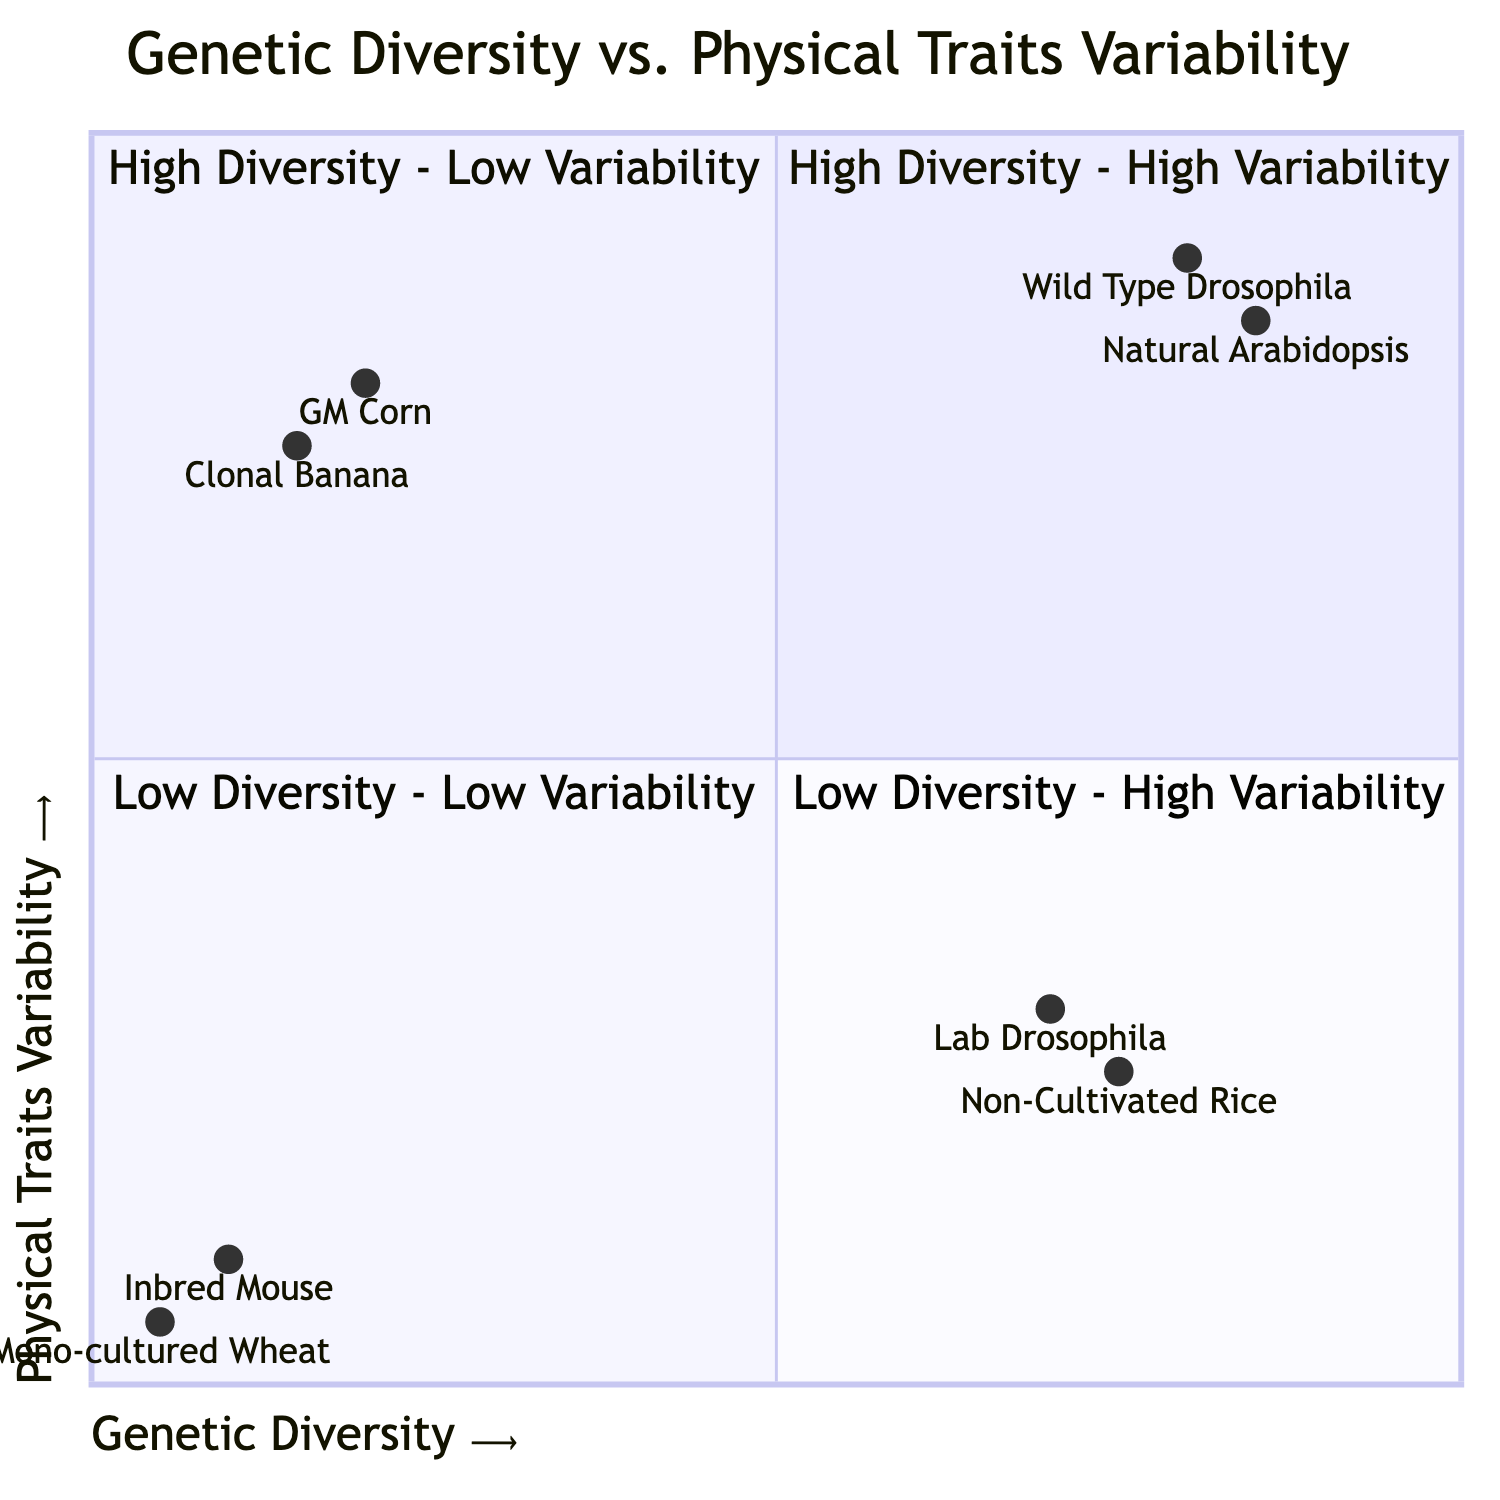What populations are located in the high genetic high variability quadrant? The quadrant labeled "High Diversity - High Variability" includes the populations of "Wild Type Drosophila Melanogaster" and "Natural Population of Arabidopsis Thaliana."
Answer: Wild Type Drosophila Melanogaster, Natural Population of Arabidopsis Thaliana How many populations are found in the low genetic low traits quadrant? The quadrant "Low Diversity - Low Variability" contains two populations: "Inbred Mouse Strains" and "Mono-cultured Wheat Fields." Therefore, the count is two.
Answer: 2 Which population exhibits the most physical traits variability in the diagram? The "Wild Type Drosophila Melanogaster" in the "High Diversity - High Variability" quadrant shows a wide range of physical traits, indicating the highest variability.
Answer: Wild Type Drosophila Melanogaster What is the observed trait for "Lab-Maintained Drosophila Melanogaster"? In the "High Diversity - Low Variability" quadrant, the observed trait for "Lab-Maintained Drosophila Melanogaster" is "Minor differences in physical traits due to controlled environment."
Answer: Minor differences in physical traits due to controlled environment Which quadrant contains "Genetically Modified Corn"? The "Genetically Modified Corn" is located in the "Low Diversity - High Variability" quadrant, indicating it has low genetic diversity but a range of trait expressions.
Answer: Low Diversity - High Variability What trend is observed in the "Non-Cultivated Rice Varieties"? "Non-Cultivated Rice Varieties" are found in the "High Diversity - Low Variability" quadrant, where many genetic variations lead to stable trait expressions, indicating stabilizing effects.
Answer: High Diversity - Low Variability How are genetic variants correlated with physical traits in the "Inbred Mouse Strains"? "Inbred Mouse Strains," located in the "Low Diversity - Low Variability" quadrant, have minimal genetic variation, leading to consistent physical traits such as body size and coat color.
Answer: Minimal genetic variation leads to consistent traits What is the relationship between genetic diversity and physical traits in "Clonal Propagation of Banana"? The "Clonal Propagation of Banana," situated in the "Low Diversity - High Variability" quadrant, has low genetic variation but significant differences in traits due to environmental factors.
Answer: Low genetic variation, significant trait differences due to environment 